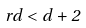<formula> <loc_0><loc_0><loc_500><loc_500>r d < d + 2</formula> 